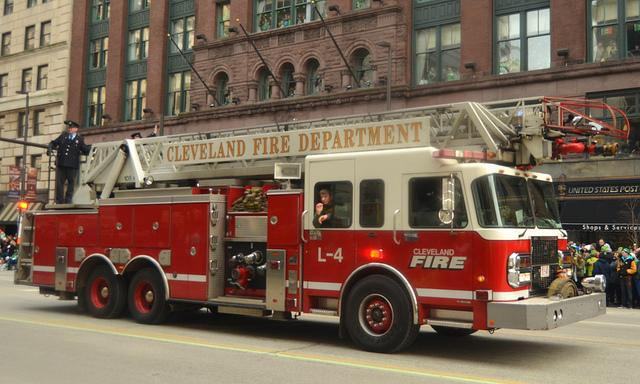What state is this city in? ohio 